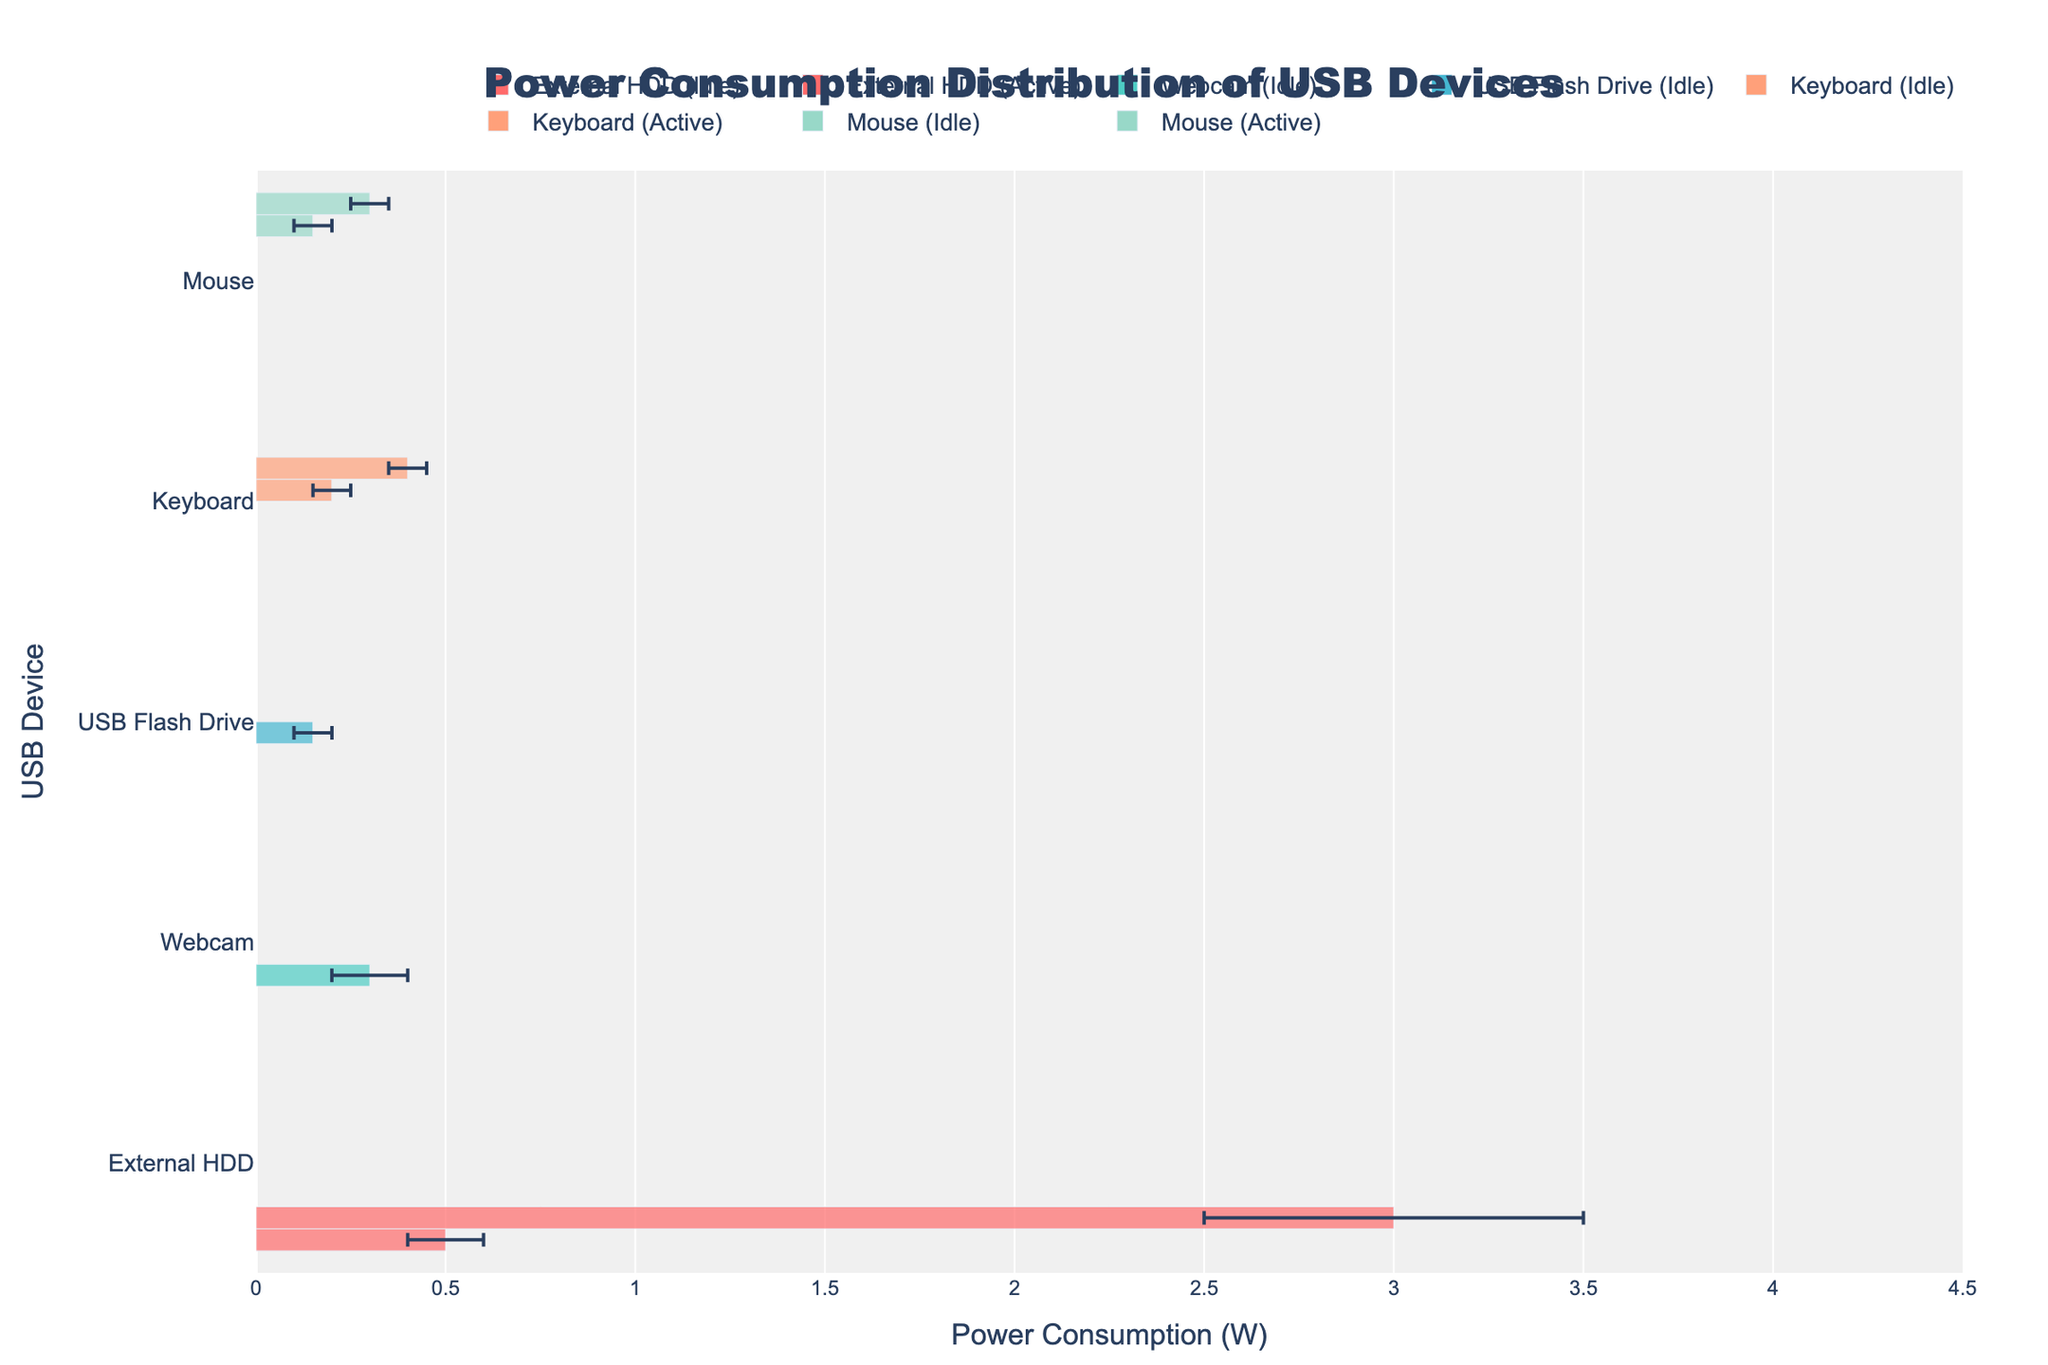How many different USB devices are shown in the chart? The chart displays various USB devices grouped accordingly. By counting the distinct groups along the y-axis, we can determine the number of devices.
Answer: 5 Which device has the highest median power consumption when active? Observe the bars representing the active condition for each device. The External HDD's bar extends furthest to the right, indicating the highest median power consumption.
Answer: External HDD What is the range of power consumption for the Webcam when streaming? For the Webcam under streaming conditions, the range is determined by subtracting the minimum value from the maximum value in the hover information.
Answer: 1.9 W What is the median power consumption for the USB Flash Drive when idle? Identify the USB Flash Drive bar corresponding to the idle state and read the median value from the hover information.
Answer: 0.15 W Which device has the smallest difference between the Q1 and Q3 values in the active load condition? Calculate the difference (Q3-Q1) for the active load condition of each device using the hover information. Compare these differences to identify the smallest one.
Answer: Mouse How does the power consumption distribution of the Keyboard differ between idle and active conditions in terms of range? Compare the min-max ranges for both idle and active conditions of the Keyboard. For idle, it's 0.1 to 0.3, and for active, it's 0.3 to 0.5.
Answer: Idle: 0.2 W, Active: 0.2 W Which device consumes more power when idle, the Webcam or the Mouse? Compare the median values of the Webcam and Mouse under idle conditions from the hover information.
Answer: Webcam How does the interquartile range (Q3-Q1) of the External HDD when idle compare to that of the USB Flash Drive during read/write? Calculate the interquartile range for both conditions: External HDD (Idle) and USB Flash Drive (Read/Write), using their respective Q3 and Q1 values. Compare the results.
Answer: External HDD: 0.2 W, USB Flash Drive: 0.2 W Which device's power consumption varies the most when active? Based on the maximum difference between Min and Max values within the active state, the External HDD shows the largest variation.
Answer: External HDD What is the average median power consumption of the Keyboard in both idle and active states? Add the median values of the Keyboard in both states and divide by 2. Idle median: 0.2, Active median: 0.4. (0.2 + 0.4) / 2 = 0.3.
Answer: 0.3 W 